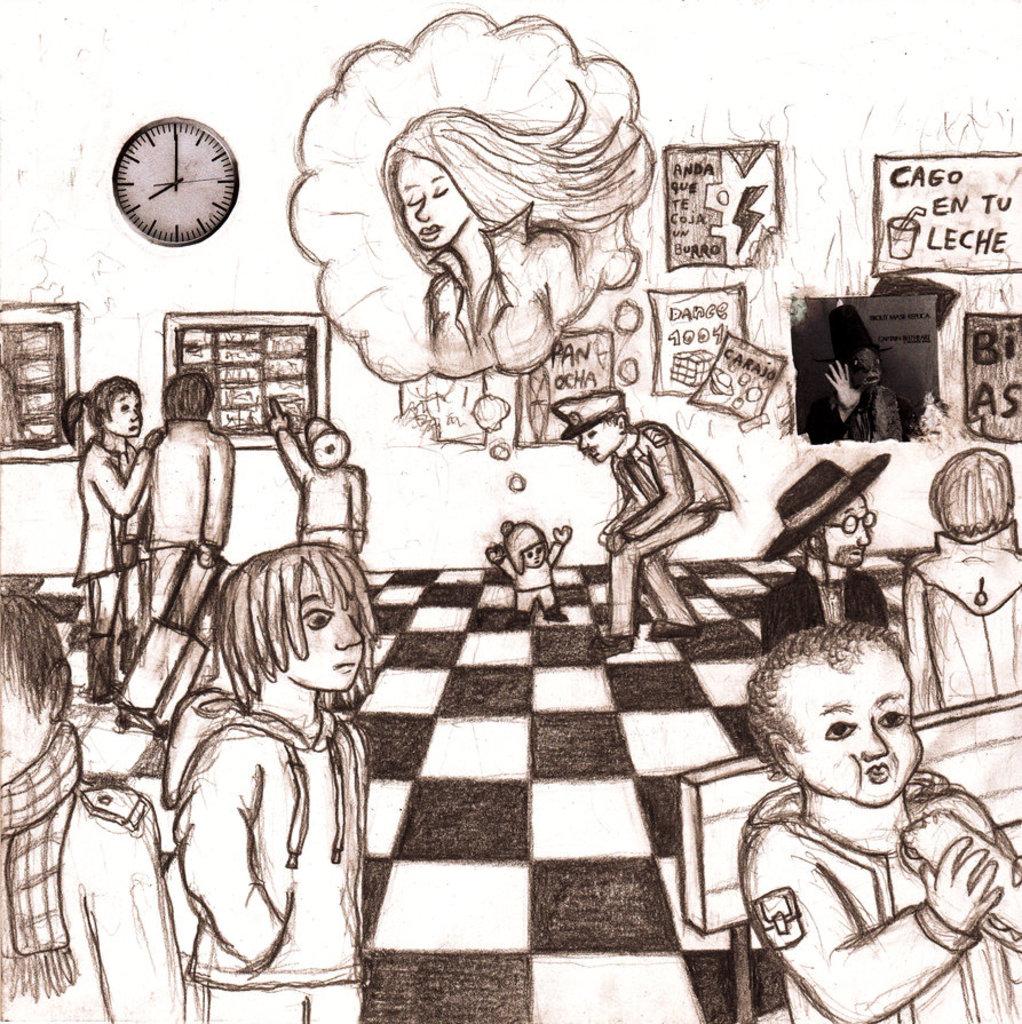What time is displayed on the clock?
Ensure brevity in your answer.  8:00. What does the top right sign say?
Provide a succinct answer. Cago en tu leche. 